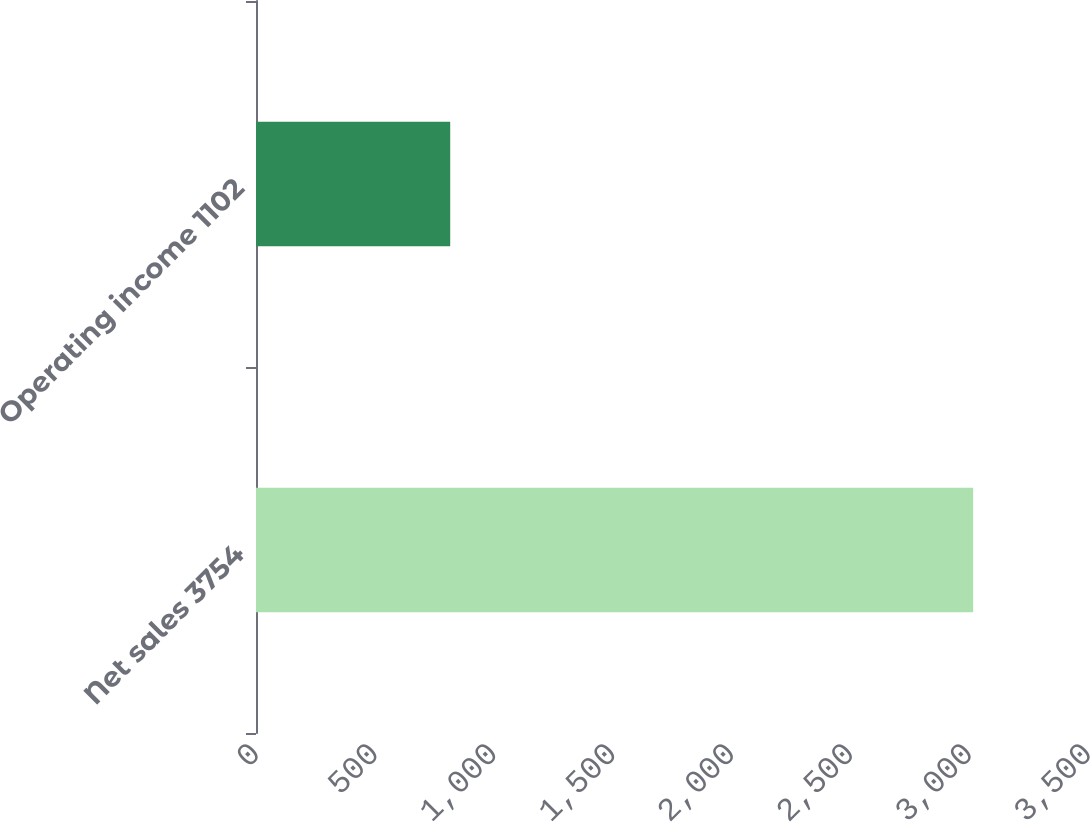Convert chart to OTSL. <chart><loc_0><loc_0><loc_500><loc_500><bar_chart><fcel>Net sales 3754<fcel>Operating income 1102<nl><fcel>3017<fcel>817<nl></chart> 